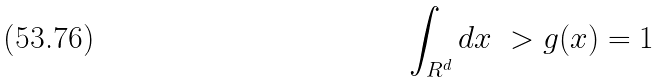Convert formula to latex. <formula><loc_0><loc_0><loc_500><loc_500>\int _ { { R } ^ { d } } d x \ > g ( x ) = 1</formula> 